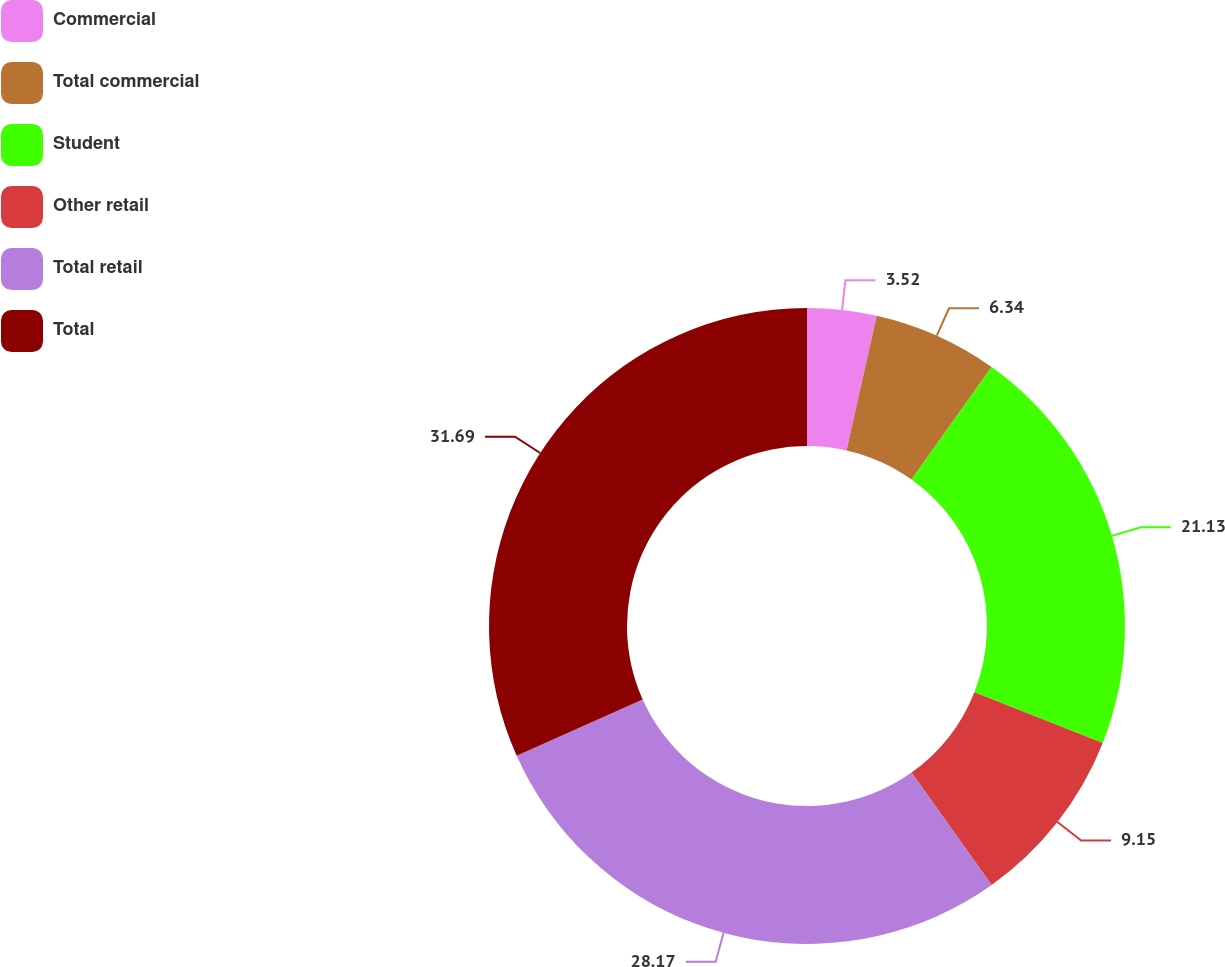Convert chart to OTSL. <chart><loc_0><loc_0><loc_500><loc_500><pie_chart><fcel>Commercial<fcel>Total commercial<fcel>Student<fcel>Other retail<fcel>Total retail<fcel>Total<nl><fcel>3.52%<fcel>6.34%<fcel>21.13%<fcel>9.15%<fcel>28.17%<fcel>31.69%<nl></chart> 